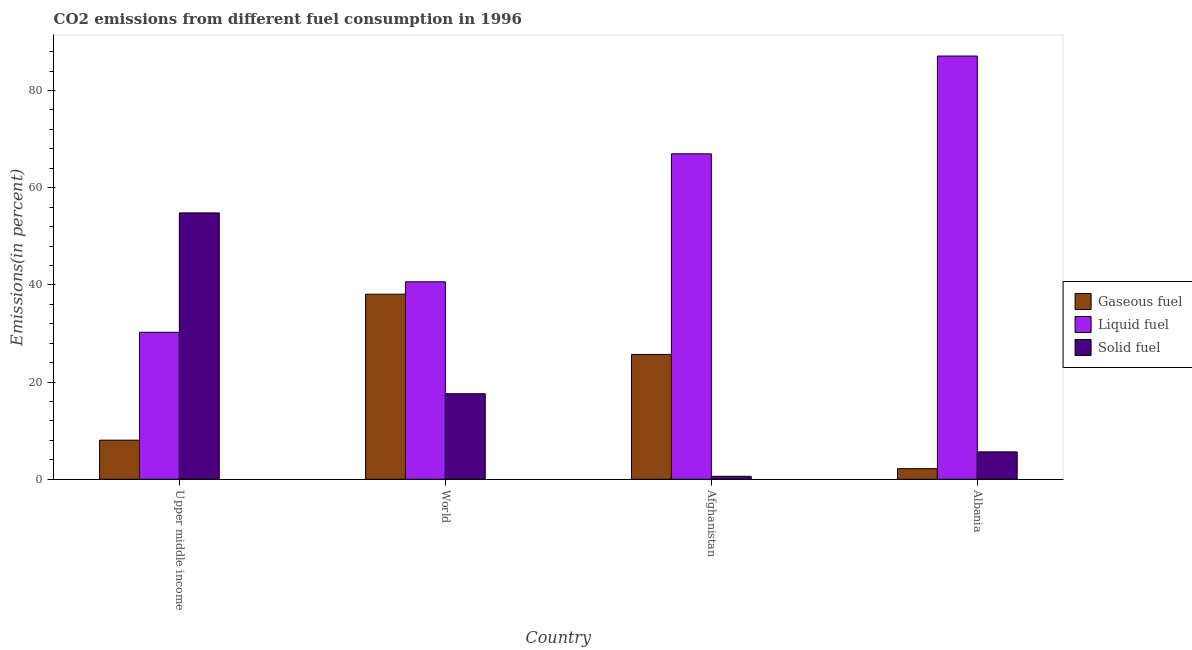How many bars are there on the 2nd tick from the left?
Your answer should be very brief. 3. How many bars are there on the 4th tick from the right?
Provide a short and direct response. 3. What is the label of the 1st group of bars from the left?
Provide a succinct answer. Upper middle income. In how many cases, is the number of bars for a given country not equal to the number of legend labels?
Your answer should be very brief. 0. What is the percentage of gaseous fuel emission in World?
Provide a short and direct response. 38.08. Across all countries, what is the maximum percentage of liquid fuel emission?
Keep it short and to the point. 87.09. Across all countries, what is the minimum percentage of liquid fuel emission?
Keep it short and to the point. 30.25. In which country was the percentage of solid fuel emission maximum?
Make the answer very short. Upper middle income. In which country was the percentage of liquid fuel emission minimum?
Provide a short and direct response. Upper middle income. What is the total percentage of solid fuel emission in the graph?
Offer a terse response. 78.66. What is the difference between the percentage of gaseous fuel emission in Afghanistan and that in World?
Ensure brevity in your answer.  -12.4. What is the difference between the percentage of solid fuel emission in Afghanistan and the percentage of liquid fuel emission in World?
Provide a succinct answer. -40.02. What is the average percentage of gaseous fuel emission per country?
Offer a very short reply. 18.5. What is the difference between the percentage of liquid fuel emission and percentage of solid fuel emission in Albania?
Provide a succinct answer. 81.45. What is the ratio of the percentage of solid fuel emission in Afghanistan to that in World?
Make the answer very short. 0.03. What is the difference between the highest and the second highest percentage of liquid fuel emission?
Your answer should be very brief. 20.12. What is the difference between the highest and the lowest percentage of solid fuel emission?
Keep it short and to the point. 54.2. What does the 3rd bar from the left in Afghanistan represents?
Your answer should be compact. Solid fuel. What does the 3rd bar from the right in Albania represents?
Provide a short and direct response. Gaseous fuel. Is it the case that in every country, the sum of the percentage of gaseous fuel emission and percentage of liquid fuel emission is greater than the percentage of solid fuel emission?
Keep it short and to the point. No. Are all the bars in the graph horizontal?
Offer a terse response. No. How many countries are there in the graph?
Give a very brief answer. 4. What is the difference between two consecutive major ticks on the Y-axis?
Ensure brevity in your answer.  20. Are the values on the major ticks of Y-axis written in scientific E-notation?
Make the answer very short. No. Does the graph contain any zero values?
Provide a short and direct response. No. Does the graph contain grids?
Offer a very short reply. No. Where does the legend appear in the graph?
Your response must be concise. Center right. How are the legend labels stacked?
Provide a short and direct response. Vertical. What is the title of the graph?
Keep it short and to the point. CO2 emissions from different fuel consumption in 1996. What is the label or title of the Y-axis?
Keep it short and to the point. Emissions(in percent). What is the Emissions(in percent) of Gaseous fuel in Upper middle income?
Your response must be concise. 8.05. What is the Emissions(in percent) in Liquid fuel in Upper middle income?
Provide a succinct answer. 30.25. What is the Emissions(in percent) in Solid fuel in Upper middle income?
Your response must be concise. 54.81. What is the Emissions(in percent) in Gaseous fuel in World?
Keep it short and to the point. 38.08. What is the Emissions(in percent) of Liquid fuel in World?
Your answer should be very brief. 40.63. What is the Emissions(in percent) of Solid fuel in World?
Make the answer very short. 17.6. What is the Emissions(in percent) in Gaseous fuel in Afghanistan?
Your answer should be compact. 25.69. What is the Emissions(in percent) in Liquid fuel in Afghanistan?
Your answer should be compact. 66.97. What is the Emissions(in percent) of Solid fuel in Afghanistan?
Your answer should be compact. 0.61. What is the Emissions(in percent) of Gaseous fuel in Albania?
Ensure brevity in your answer.  2.18. What is the Emissions(in percent) of Liquid fuel in Albania?
Your answer should be very brief. 87.09. What is the Emissions(in percent) in Solid fuel in Albania?
Your response must be concise. 5.64. Across all countries, what is the maximum Emissions(in percent) in Gaseous fuel?
Offer a very short reply. 38.08. Across all countries, what is the maximum Emissions(in percent) in Liquid fuel?
Your answer should be very brief. 87.09. Across all countries, what is the maximum Emissions(in percent) in Solid fuel?
Make the answer very short. 54.81. Across all countries, what is the minimum Emissions(in percent) in Gaseous fuel?
Offer a very short reply. 2.18. Across all countries, what is the minimum Emissions(in percent) in Liquid fuel?
Your response must be concise. 30.25. Across all countries, what is the minimum Emissions(in percent) in Solid fuel?
Your response must be concise. 0.61. What is the total Emissions(in percent) of Gaseous fuel in the graph?
Offer a very short reply. 74. What is the total Emissions(in percent) of Liquid fuel in the graph?
Make the answer very short. 224.95. What is the total Emissions(in percent) in Solid fuel in the graph?
Provide a succinct answer. 78.66. What is the difference between the Emissions(in percent) in Gaseous fuel in Upper middle income and that in World?
Keep it short and to the point. -30.04. What is the difference between the Emissions(in percent) of Liquid fuel in Upper middle income and that in World?
Provide a succinct answer. -10.38. What is the difference between the Emissions(in percent) of Solid fuel in Upper middle income and that in World?
Your answer should be very brief. 37.21. What is the difference between the Emissions(in percent) in Gaseous fuel in Upper middle income and that in Afghanistan?
Offer a very short reply. -17.64. What is the difference between the Emissions(in percent) of Liquid fuel in Upper middle income and that in Afghanistan?
Keep it short and to the point. -36.72. What is the difference between the Emissions(in percent) in Solid fuel in Upper middle income and that in Afghanistan?
Ensure brevity in your answer.  54.2. What is the difference between the Emissions(in percent) in Gaseous fuel in Upper middle income and that in Albania?
Provide a short and direct response. 5.86. What is the difference between the Emissions(in percent) in Liquid fuel in Upper middle income and that in Albania?
Your answer should be very brief. -56.84. What is the difference between the Emissions(in percent) in Solid fuel in Upper middle income and that in Albania?
Give a very brief answer. 49.18. What is the difference between the Emissions(in percent) of Gaseous fuel in World and that in Afghanistan?
Offer a terse response. 12.4. What is the difference between the Emissions(in percent) in Liquid fuel in World and that in Afghanistan?
Provide a short and direct response. -26.34. What is the difference between the Emissions(in percent) in Solid fuel in World and that in Afghanistan?
Make the answer very short. 16.99. What is the difference between the Emissions(in percent) of Gaseous fuel in World and that in Albania?
Your answer should be compact. 35.9. What is the difference between the Emissions(in percent) of Liquid fuel in World and that in Albania?
Ensure brevity in your answer.  -46.46. What is the difference between the Emissions(in percent) in Solid fuel in World and that in Albania?
Offer a terse response. 11.96. What is the difference between the Emissions(in percent) of Gaseous fuel in Afghanistan and that in Albania?
Offer a very short reply. 23.51. What is the difference between the Emissions(in percent) of Liquid fuel in Afghanistan and that in Albania?
Your answer should be compact. -20.12. What is the difference between the Emissions(in percent) in Solid fuel in Afghanistan and that in Albania?
Offer a terse response. -5.02. What is the difference between the Emissions(in percent) in Gaseous fuel in Upper middle income and the Emissions(in percent) in Liquid fuel in World?
Offer a very short reply. -32.59. What is the difference between the Emissions(in percent) in Gaseous fuel in Upper middle income and the Emissions(in percent) in Solid fuel in World?
Give a very brief answer. -9.55. What is the difference between the Emissions(in percent) in Liquid fuel in Upper middle income and the Emissions(in percent) in Solid fuel in World?
Give a very brief answer. 12.65. What is the difference between the Emissions(in percent) in Gaseous fuel in Upper middle income and the Emissions(in percent) in Liquid fuel in Afghanistan?
Give a very brief answer. -58.93. What is the difference between the Emissions(in percent) in Gaseous fuel in Upper middle income and the Emissions(in percent) in Solid fuel in Afghanistan?
Your answer should be very brief. 7.43. What is the difference between the Emissions(in percent) in Liquid fuel in Upper middle income and the Emissions(in percent) in Solid fuel in Afghanistan?
Your answer should be compact. 29.64. What is the difference between the Emissions(in percent) in Gaseous fuel in Upper middle income and the Emissions(in percent) in Liquid fuel in Albania?
Your response must be concise. -79.04. What is the difference between the Emissions(in percent) of Gaseous fuel in Upper middle income and the Emissions(in percent) of Solid fuel in Albania?
Your answer should be very brief. 2.41. What is the difference between the Emissions(in percent) of Liquid fuel in Upper middle income and the Emissions(in percent) of Solid fuel in Albania?
Ensure brevity in your answer.  24.61. What is the difference between the Emissions(in percent) of Gaseous fuel in World and the Emissions(in percent) of Liquid fuel in Afghanistan?
Keep it short and to the point. -28.89. What is the difference between the Emissions(in percent) in Gaseous fuel in World and the Emissions(in percent) in Solid fuel in Afghanistan?
Your response must be concise. 37.47. What is the difference between the Emissions(in percent) of Liquid fuel in World and the Emissions(in percent) of Solid fuel in Afghanistan?
Your answer should be very brief. 40.02. What is the difference between the Emissions(in percent) in Gaseous fuel in World and the Emissions(in percent) in Liquid fuel in Albania?
Provide a short and direct response. -49.01. What is the difference between the Emissions(in percent) in Gaseous fuel in World and the Emissions(in percent) in Solid fuel in Albania?
Provide a short and direct response. 32.45. What is the difference between the Emissions(in percent) of Liquid fuel in World and the Emissions(in percent) of Solid fuel in Albania?
Give a very brief answer. 35. What is the difference between the Emissions(in percent) of Gaseous fuel in Afghanistan and the Emissions(in percent) of Liquid fuel in Albania?
Your answer should be compact. -61.4. What is the difference between the Emissions(in percent) of Gaseous fuel in Afghanistan and the Emissions(in percent) of Solid fuel in Albania?
Provide a succinct answer. 20.05. What is the difference between the Emissions(in percent) of Liquid fuel in Afghanistan and the Emissions(in percent) of Solid fuel in Albania?
Offer a terse response. 61.34. What is the average Emissions(in percent) in Gaseous fuel per country?
Your response must be concise. 18.5. What is the average Emissions(in percent) in Liquid fuel per country?
Give a very brief answer. 56.24. What is the average Emissions(in percent) in Solid fuel per country?
Ensure brevity in your answer.  19.67. What is the difference between the Emissions(in percent) in Gaseous fuel and Emissions(in percent) in Liquid fuel in Upper middle income?
Your response must be concise. -22.2. What is the difference between the Emissions(in percent) in Gaseous fuel and Emissions(in percent) in Solid fuel in Upper middle income?
Offer a terse response. -46.77. What is the difference between the Emissions(in percent) of Liquid fuel and Emissions(in percent) of Solid fuel in Upper middle income?
Offer a very short reply. -24.56. What is the difference between the Emissions(in percent) in Gaseous fuel and Emissions(in percent) in Liquid fuel in World?
Your response must be concise. -2.55. What is the difference between the Emissions(in percent) in Gaseous fuel and Emissions(in percent) in Solid fuel in World?
Provide a short and direct response. 20.48. What is the difference between the Emissions(in percent) of Liquid fuel and Emissions(in percent) of Solid fuel in World?
Provide a short and direct response. 23.03. What is the difference between the Emissions(in percent) of Gaseous fuel and Emissions(in percent) of Liquid fuel in Afghanistan?
Your response must be concise. -41.28. What is the difference between the Emissions(in percent) of Gaseous fuel and Emissions(in percent) of Solid fuel in Afghanistan?
Ensure brevity in your answer.  25.08. What is the difference between the Emissions(in percent) of Liquid fuel and Emissions(in percent) of Solid fuel in Afghanistan?
Make the answer very short. 66.36. What is the difference between the Emissions(in percent) in Gaseous fuel and Emissions(in percent) in Liquid fuel in Albania?
Offer a terse response. -84.91. What is the difference between the Emissions(in percent) in Gaseous fuel and Emissions(in percent) in Solid fuel in Albania?
Provide a short and direct response. -3.45. What is the difference between the Emissions(in percent) in Liquid fuel and Emissions(in percent) in Solid fuel in Albania?
Offer a terse response. 81.45. What is the ratio of the Emissions(in percent) of Gaseous fuel in Upper middle income to that in World?
Your response must be concise. 0.21. What is the ratio of the Emissions(in percent) of Liquid fuel in Upper middle income to that in World?
Your response must be concise. 0.74. What is the ratio of the Emissions(in percent) of Solid fuel in Upper middle income to that in World?
Offer a terse response. 3.11. What is the ratio of the Emissions(in percent) of Gaseous fuel in Upper middle income to that in Afghanistan?
Ensure brevity in your answer.  0.31. What is the ratio of the Emissions(in percent) in Liquid fuel in Upper middle income to that in Afghanistan?
Your answer should be very brief. 0.45. What is the ratio of the Emissions(in percent) of Solid fuel in Upper middle income to that in Afghanistan?
Give a very brief answer. 89.62. What is the ratio of the Emissions(in percent) in Gaseous fuel in Upper middle income to that in Albania?
Keep it short and to the point. 3.69. What is the ratio of the Emissions(in percent) of Liquid fuel in Upper middle income to that in Albania?
Provide a succinct answer. 0.35. What is the ratio of the Emissions(in percent) in Solid fuel in Upper middle income to that in Albania?
Keep it short and to the point. 9.72. What is the ratio of the Emissions(in percent) of Gaseous fuel in World to that in Afghanistan?
Give a very brief answer. 1.48. What is the ratio of the Emissions(in percent) in Liquid fuel in World to that in Afghanistan?
Make the answer very short. 0.61. What is the ratio of the Emissions(in percent) in Solid fuel in World to that in Afghanistan?
Your answer should be compact. 28.78. What is the ratio of the Emissions(in percent) in Gaseous fuel in World to that in Albania?
Provide a short and direct response. 17.46. What is the ratio of the Emissions(in percent) of Liquid fuel in World to that in Albania?
Your answer should be compact. 0.47. What is the ratio of the Emissions(in percent) in Solid fuel in World to that in Albania?
Provide a short and direct response. 3.12. What is the ratio of the Emissions(in percent) in Gaseous fuel in Afghanistan to that in Albania?
Provide a short and direct response. 11.77. What is the ratio of the Emissions(in percent) in Liquid fuel in Afghanistan to that in Albania?
Give a very brief answer. 0.77. What is the ratio of the Emissions(in percent) of Solid fuel in Afghanistan to that in Albania?
Offer a terse response. 0.11. What is the difference between the highest and the second highest Emissions(in percent) of Gaseous fuel?
Make the answer very short. 12.4. What is the difference between the highest and the second highest Emissions(in percent) of Liquid fuel?
Offer a very short reply. 20.12. What is the difference between the highest and the second highest Emissions(in percent) of Solid fuel?
Give a very brief answer. 37.21. What is the difference between the highest and the lowest Emissions(in percent) of Gaseous fuel?
Give a very brief answer. 35.9. What is the difference between the highest and the lowest Emissions(in percent) in Liquid fuel?
Offer a terse response. 56.84. What is the difference between the highest and the lowest Emissions(in percent) in Solid fuel?
Make the answer very short. 54.2. 